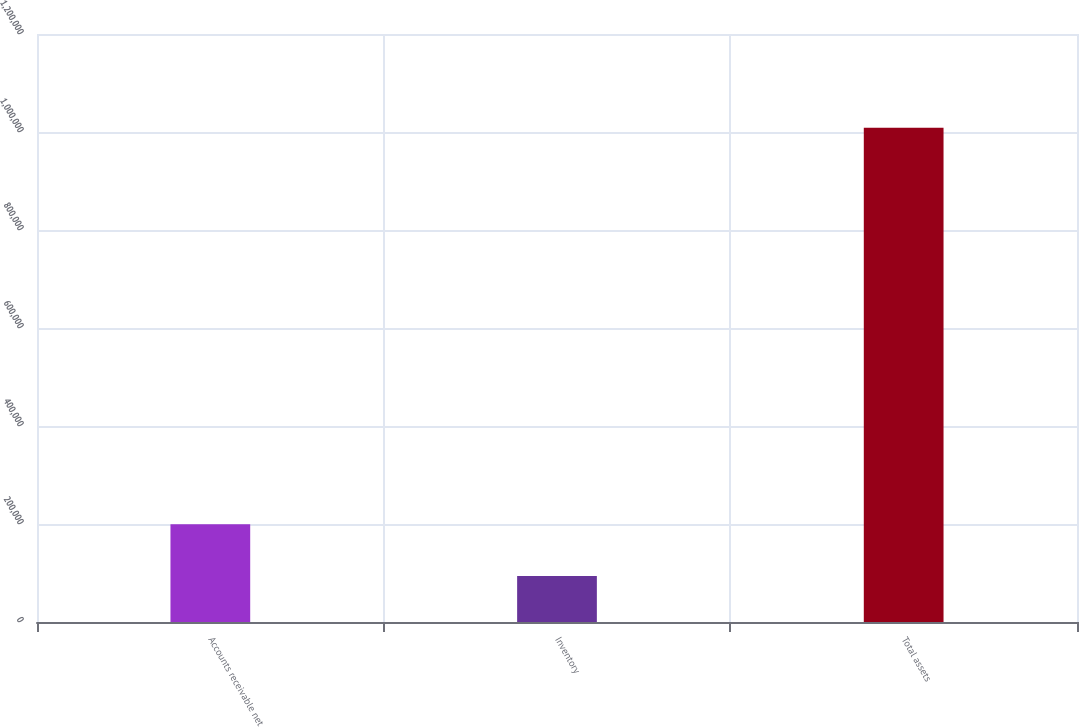Convert chart to OTSL. <chart><loc_0><loc_0><loc_500><loc_500><bar_chart><fcel>Accounts receivable net<fcel>Inventory<fcel>Total assets<nl><fcel>199395<fcel>93996<fcel>1.00857e+06<nl></chart> 